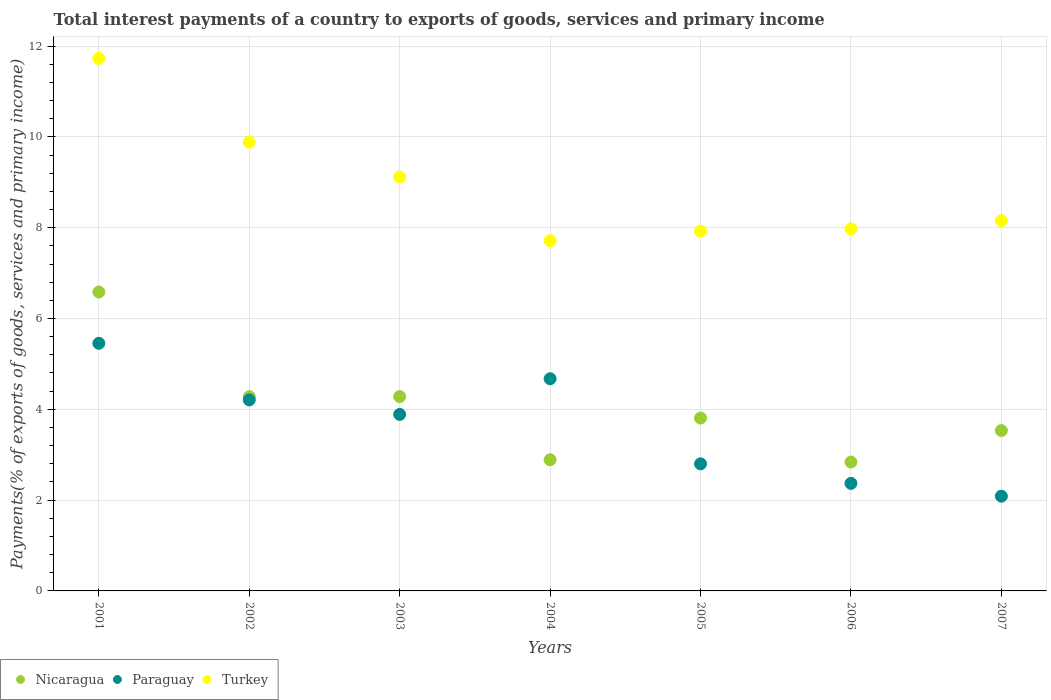How many different coloured dotlines are there?
Keep it short and to the point. 3. Is the number of dotlines equal to the number of legend labels?
Your response must be concise. Yes. What is the total interest payments in Turkey in 2003?
Provide a succinct answer. 9.12. Across all years, what is the maximum total interest payments in Turkey?
Provide a succinct answer. 11.73. Across all years, what is the minimum total interest payments in Nicaragua?
Keep it short and to the point. 2.84. In which year was the total interest payments in Paraguay maximum?
Offer a terse response. 2001. In which year was the total interest payments in Turkey minimum?
Provide a succinct answer. 2004. What is the total total interest payments in Turkey in the graph?
Keep it short and to the point. 62.5. What is the difference between the total interest payments in Nicaragua in 2003 and that in 2005?
Make the answer very short. 0.47. What is the difference between the total interest payments in Nicaragua in 2002 and the total interest payments in Turkey in 2003?
Ensure brevity in your answer.  -4.84. What is the average total interest payments in Turkey per year?
Provide a short and direct response. 8.93. In the year 2007, what is the difference between the total interest payments in Turkey and total interest payments in Paraguay?
Keep it short and to the point. 6.07. In how many years, is the total interest payments in Nicaragua greater than 11.6 %?
Offer a terse response. 0. What is the ratio of the total interest payments in Turkey in 2006 to that in 2007?
Provide a short and direct response. 0.98. Is the difference between the total interest payments in Turkey in 2004 and 2007 greater than the difference between the total interest payments in Paraguay in 2004 and 2007?
Give a very brief answer. No. What is the difference between the highest and the second highest total interest payments in Paraguay?
Your answer should be very brief. 0.78. What is the difference between the highest and the lowest total interest payments in Turkey?
Keep it short and to the point. 4.02. In how many years, is the total interest payments in Nicaragua greater than the average total interest payments in Nicaragua taken over all years?
Provide a succinct answer. 3. How many legend labels are there?
Keep it short and to the point. 3. What is the title of the graph?
Ensure brevity in your answer.  Total interest payments of a country to exports of goods, services and primary income. What is the label or title of the X-axis?
Offer a very short reply. Years. What is the label or title of the Y-axis?
Make the answer very short. Payments(% of exports of goods, services and primary income). What is the Payments(% of exports of goods, services and primary income) of Nicaragua in 2001?
Offer a very short reply. 6.58. What is the Payments(% of exports of goods, services and primary income) of Paraguay in 2001?
Make the answer very short. 5.45. What is the Payments(% of exports of goods, services and primary income) in Turkey in 2001?
Provide a succinct answer. 11.73. What is the Payments(% of exports of goods, services and primary income) in Nicaragua in 2002?
Make the answer very short. 4.28. What is the Payments(% of exports of goods, services and primary income) in Paraguay in 2002?
Provide a short and direct response. 4.21. What is the Payments(% of exports of goods, services and primary income) in Turkey in 2002?
Provide a succinct answer. 9.88. What is the Payments(% of exports of goods, services and primary income) of Nicaragua in 2003?
Offer a very short reply. 4.28. What is the Payments(% of exports of goods, services and primary income) in Paraguay in 2003?
Give a very brief answer. 3.89. What is the Payments(% of exports of goods, services and primary income) in Turkey in 2003?
Make the answer very short. 9.12. What is the Payments(% of exports of goods, services and primary income) of Nicaragua in 2004?
Provide a succinct answer. 2.89. What is the Payments(% of exports of goods, services and primary income) in Paraguay in 2004?
Your answer should be compact. 4.67. What is the Payments(% of exports of goods, services and primary income) of Turkey in 2004?
Ensure brevity in your answer.  7.71. What is the Payments(% of exports of goods, services and primary income) of Nicaragua in 2005?
Your response must be concise. 3.81. What is the Payments(% of exports of goods, services and primary income) of Paraguay in 2005?
Your response must be concise. 2.8. What is the Payments(% of exports of goods, services and primary income) of Turkey in 2005?
Offer a terse response. 7.92. What is the Payments(% of exports of goods, services and primary income) of Nicaragua in 2006?
Provide a succinct answer. 2.84. What is the Payments(% of exports of goods, services and primary income) in Paraguay in 2006?
Give a very brief answer. 2.37. What is the Payments(% of exports of goods, services and primary income) in Turkey in 2006?
Your answer should be very brief. 7.97. What is the Payments(% of exports of goods, services and primary income) of Nicaragua in 2007?
Provide a short and direct response. 3.53. What is the Payments(% of exports of goods, services and primary income) in Paraguay in 2007?
Offer a very short reply. 2.09. What is the Payments(% of exports of goods, services and primary income) in Turkey in 2007?
Your answer should be very brief. 8.16. Across all years, what is the maximum Payments(% of exports of goods, services and primary income) of Nicaragua?
Offer a very short reply. 6.58. Across all years, what is the maximum Payments(% of exports of goods, services and primary income) in Paraguay?
Give a very brief answer. 5.45. Across all years, what is the maximum Payments(% of exports of goods, services and primary income) in Turkey?
Offer a terse response. 11.73. Across all years, what is the minimum Payments(% of exports of goods, services and primary income) of Nicaragua?
Provide a short and direct response. 2.84. Across all years, what is the minimum Payments(% of exports of goods, services and primary income) of Paraguay?
Give a very brief answer. 2.09. Across all years, what is the minimum Payments(% of exports of goods, services and primary income) in Turkey?
Provide a short and direct response. 7.71. What is the total Payments(% of exports of goods, services and primary income) of Nicaragua in the graph?
Your answer should be compact. 28.21. What is the total Payments(% of exports of goods, services and primary income) in Paraguay in the graph?
Give a very brief answer. 25.48. What is the total Payments(% of exports of goods, services and primary income) in Turkey in the graph?
Provide a short and direct response. 62.5. What is the difference between the Payments(% of exports of goods, services and primary income) in Nicaragua in 2001 and that in 2002?
Make the answer very short. 2.31. What is the difference between the Payments(% of exports of goods, services and primary income) of Paraguay in 2001 and that in 2002?
Ensure brevity in your answer.  1.25. What is the difference between the Payments(% of exports of goods, services and primary income) of Turkey in 2001 and that in 2002?
Offer a very short reply. 1.84. What is the difference between the Payments(% of exports of goods, services and primary income) of Nicaragua in 2001 and that in 2003?
Your answer should be very brief. 2.3. What is the difference between the Payments(% of exports of goods, services and primary income) in Paraguay in 2001 and that in 2003?
Offer a terse response. 1.57. What is the difference between the Payments(% of exports of goods, services and primary income) of Turkey in 2001 and that in 2003?
Your answer should be very brief. 2.61. What is the difference between the Payments(% of exports of goods, services and primary income) in Nicaragua in 2001 and that in 2004?
Ensure brevity in your answer.  3.7. What is the difference between the Payments(% of exports of goods, services and primary income) in Paraguay in 2001 and that in 2004?
Give a very brief answer. 0.78. What is the difference between the Payments(% of exports of goods, services and primary income) of Turkey in 2001 and that in 2004?
Provide a short and direct response. 4.02. What is the difference between the Payments(% of exports of goods, services and primary income) in Nicaragua in 2001 and that in 2005?
Your answer should be very brief. 2.78. What is the difference between the Payments(% of exports of goods, services and primary income) of Paraguay in 2001 and that in 2005?
Your answer should be very brief. 2.65. What is the difference between the Payments(% of exports of goods, services and primary income) of Turkey in 2001 and that in 2005?
Provide a short and direct response. 3.8. What is the difference between the Payments(% of exports of goods, services and primary income) in Nicaragua in 2001 and that in 2006?
Provide a succinct answer. 3.74. What is the difference between the Payments(% of exports of goods, services and primary income) of Paraguay in 2001 and that in 2006?
Offer a terse response. 3.08. What is the difference between the Payments(% of exports of goods, services and primary income) of Turkey in 2001 and that in 2006?
Ensure brevity in your answer.  3.75. What is the difference between the Payments(% of exports of goods, services and primary income) of Nicaragua in 2001 and that in 2007?
Provide a succinct answer. 3.05. What is the difference between the Payments(% of exports of goods, services and primary income) of Paraguay in 2001 and that in 2007?
Your response must be concise. 3.37. What is the difference between the Payments(% of exports of goods, services and primary income) in Turkey in 2001 and that in 2007?
Make the answer very short. 3.57. What is the difference between the Payments(% of exports of goods, services and primary income) in Nicaragua in 2002 and that in 2003?
Make the answer very short. -0. What is the difference between the Payments(% of exports of goods, services and primary income) in Paraguay in 2002 and that in 2003?
Your answer should be compact. 0.32. What is the difference between the Payments(% of exports of goods, services and primary income) in Turkey in 2002 and that in 2003?
Your answer should be compact. 0.77. What is the difference between the Payments(% of exports of goods, services and primary income) in Nicaragua in 2002 and that in 2004?
Your answer should be compact. 1.39. What is the difference between the Payments(% of exports of goods, services and primary income) in Paraguay in 2002 and that in 2004?
Your answer should be compact. -0.47. What is the difference between the Payments(% of exports of goods, services and primary income) in Turkey in 2002 and that in 2004?
Your response must be concise. 2.17. What is the difference between the Payments(% of exports of goods, services and primary income) in Nicaragua in 2002 and that in 2005?
Give a very brief answer. 0.47. What is the difference between the Payments(% of exports of goods, services and primary income) of Paraguay in 2002 and that in 2005?
Make the answer very short. 1.41. What is the difference between the Payments(% of exports of goods, services and primary income) of Turkey in 2002 and that in 2005?
Make the answer very short. 1.96. What is the difference between the Payments(% of exports of goods, services and primary income) in Nicaragua in 2002 and that in 2006?
Keep it short and to the point. 1.44. What is the difference between the Payments(% of exports of goods, services and primary income) in Paraguay in 2002 and that in 2006?
Offer a terse response. 1.84. What is the difference between the Payments(% of exports of goods, services and primary income) of Turkey in 2002 and that in 2006?
Your answer should be very brief. 1.91. What is the difference between the Payments(% of exports of goods, services and primary income) in Nicaragua in 2002 and that in 2007?
Your response must be concise. 0.75. What is the difference between the Payments(% of exports of goods, services and primary income) in Paraguay in 2002 and that in 2007?
Your answer should be compact. 2.12. What is the difference between the Payments(% of exports of goods, services and primary income) in Turkey in 2002 and that in 2007?
Provide a short and direct response. 1.73. What is the difference between the Payments(% of exports of goods, services and primary income) of Nicaragua in 2003 and that in 2004?
Make the answer very short. 1.39. What is the difference between the Payments(% of exports of goods, services and primary income) in Paraguay in 2003 and that in 2004?
Provide a succinct answer. -0.79. What is the difference between the Payments(% of exports of goods, services and primary income) in Turkey in 2003 and that in 2004?
Keep it short and to the point. 1.41. What is the difference between the Payments(% of exports of goods, services and primary income) in Nicaragua in 2003 and that in 2005?
Your response must be concise. 0.47. What is the difference between the Payments(% of exports of goods, services and primary income) in Paraguay in 2003 and that in 2005?
Ensure brevity in your answer.  1.09. What is the difference between the Payments(% of exports of goods, services and primary income) of Turkey in 2003 and that in 2005?
Make the answer very short. 1.19. What is the difference between the Payments(% of exports of goods, services and primary income) in Nicaragua in 2003 and that in 2006?
Ensure brevity in your answer.  1.44. What is the difference between the Payments(% of exports of goods, services and primary income) of Paraguay in 2003 and that in 2006?
Keep it short and to the point. 1.52. What is the difference between the Payments(% of exports of goods, services and primary income) of Turkey in 2003 and that in 2006?
Offer a very short reply. 1.14. What is the difference between the Payments(% of exports of goods, services and primary income) of Nicaragua in 2003 and that in 2007?
Give a very brief answer. 0.75. What is the difference between the Payments(% of exports of goods, services and primary income) in Paraguay in 2003 and that in 2007?
Your answer should be very brief. 1.8. What is the difference between the Payments(% of exports of goods, services and primary income) in Turkey in 2003 and that in 2007?
Provide a succinct answer. 0.96. What is the difference between the Payments(% of exports of goods, services and primary income) of Nicaragua in 2004 and that in 2005?
Ensure brevity in your answer.  -0.92. What is the difference between the Payments(% of exports of goods, services and primary income) of Paraguay in 2004 and that in 2005?
Offer a very short reply. 1.87. What is the difference between the Payments(% of exports of goods, services and primary income) in Turkey in 2004 and that in 2005?
Keep it short and to the point. -0.21. What is the difference between the Payments(% of exports of goods, services and primary income) of Nicaragua in 2004 and that in 2006?
Provide a succinct answer. 0.05. What is the difference between the Payments(% of exports of goods, services and primary income) of Paraguay in 2004 and that in 2006?
Your answer should be compact. 2.3. What is the difference between the Payments(% of exports of goods, services and primary income) in Turkey in 2004 and that in 2006?
Your answer should be very brief. -0.26. What is the difference between the Payments(% of exports of goods, services and primary income) in Nicaragua in 2004 and that in 2007?
Ensure brevity in your answer.  -0.64. What is the difference between the Payments(% of exports of goods, services and primary income) in Paraguay in 2004 and that in 2007?
Give a very brief answer. 2.59. What is the difference between the Payments(% of exports of goods, services and primary income) in Turkey in 2004 and that in 2007?
Ensure brevity in your answer.  -0.44. What is the difference between the Payments(% of exports of goods, services and primary income) of Nicaragua in 2005 and that in 2006?
Give a very brief answer. 0.97. What is the difference between the Payments(% of exports of goods, services and primary income) of Paraguay in 2005 and that in 2006?
Provide a short and direct response. 0.43. What is the difference between the Payments(% of exports of goods, services and primary income) in Turkey in 2005 and that in 2006?
Offer a very short reply. -0.05. What is the difference between the Payments(% of exports of goods, services and primary income) of Nicaragua in 2005 and that in 2007?
Provide a succinct answer. 0.28. What is the difference between the Payments(% of exports of goods, services and primary income) of Paraguay in 2005 and that in 2007?
Offer a very short reply. 0.71. What is the difference between the Payments(% of exports of goods, services and primary income) in Turkey in 2005 and that in 2007?
Give a very brief answer. -0.23. What is the difference between the Payments(% of exports of goods, services and primary income) in Nicaragua in 2006 and that in 2007?
Your answer should be compact. -0.69. What is the difference between the Payments(% of exports of goods, services and primary income) of Paraguay in 2006 and that in 2007?
Give a very brief answer. 0.28. What is the difference between the Payments(% of exports of goods, services and primary income) of Turkey in 2006 and that in 2007?
Provide a succinct answer. -0.18. What is the difference between the Payments(% of exports of goods, services and primary income) in Nicaragua in 2001 and the Payments(% of exports of goods, services and primary income) in Paraguay in 2002?
Ensure brevity in your answer.  2.38. What is the difference between the Payments(% of exports of goods, services and primary income) of Nicaragua in 2001 and the Payments(% of exports of goods, services and primary income) of Turkey in 2002?
Ensure brevity in your answer.  -3.3. What is the difference between the Payments(% of exports of goods, services and primary income) of Paraguay in 2001 and the Payments(% of exports of goods, services and primary income) of Turkey in 2002?
Your answer should be compact. -4.43. What is the difference between the Payments(% of exports of goods, services and primary income) of Nicaragua in 2001 and the Payments(% of exports of goods, services and primary income) of Paraguay in 2003?
Your answer should be compact. 2.7. What is the difference between the Payments(% of exports of goods, services and primary income) in Nicaragua in 2001 and the Payments(% of exports of goods, services and primary income) in Turkey in 2003?
Keep it short and to the point. -2.54. What is the difference between the Payments(% of exports of goods, services and primary income) in Paraguay in 2001 and the Payments(% of exports of goods, services and primary income) in Turkey in 2003?
Your response must be concise. -3.67. What is the difference between the Payments(% of exports of goods, services and primary income) of Nicaragua in 2001 and the Payments(% of exports of goods, services and primary income) of Paraguay in 2004?
Your answer should be very brief. 1.91. What is the difference between the Payments(% of exports of goods, services and primary income) of Nicaragua in 2001 and the Payments(% of exports of goods, services and primary income) of Turkey in 2004?
Make the answer very short. -1.13. What is the difference between the Payments(% of exports of goods, services and primary income) in Paraguay in 2001 and the Payments(% of exports of goods, services and primary income) in Turkey in 2004?
Provide a short and direct response. -2.26. What is the difference between the Payments(% of exports of goods, services and primary income) in Nicaragua in 2001 and the Payments(% of exports of goods, services and primary income) in Paraguay in 2005?
Ensure brevity in your answer.  3.78. What is the difference between the Payments(% of exports of goods, services and primary income) of Nicaragua in 2001 and the Payments(% of exports of goods, services and primary income) of Turkey in 2005?
Give a very brief answer. -1.34. What is the difference between the Payments(% of exports of goods, services and primary income) of Paraguay in 2001 and the Payments(% of exports of goods, services and primary income) of Turkey in 2005?
Offer a very short reply. -2.47. What is the difference between the Payments(% of exports of goods, services and primary income) of Nicaragua in 2001 and the Payments(% of exports of goods, services and primary income) of Paraguay in 2006?
Your answer should be compact. 4.22. What is the difference between the Payments(% of exports of goods, services and primary income) in Nicaragua in 2001 and the Payments(% of exports of goods, services and primary income) in Turkey in 2006?
Your answer should be very brief. -1.39. What is the difference between the Payments(% of exports of goods, services and primary income) of Paraguay in 2001 and the Payments(% of exports of goods, services and primary income) of Turkey in 2006?
Provide a short and direct response. -2.52. What is the difference between the Payments(% of exports of goods, services and primary income) of Nicaragua in 2001 and the Payments(% of exports of goods, services and primary income) of Paraguay in 2007?
Your answer should be compact. 4.5. What is the difference between the Payments(% of exports of goods, services and primary income) of Nicaragua in 2001 and the Payments(% of exports of goods, services and primary income) of Turkey in 2007?
Your answer should be very brief. -1.57. What is the difference between the Payments(% of exports of goods, services and primary income) of Paraguay in 2001 and the Payments(% of exports of goods, services and primary income) of Turkey in 2007?
Offer a very short reply. -2.7. What is the difference between the Payments(% of exports of goods, services and primary income) in Nicaragua in 2002 and the Payments(% of exports of goods, services and primary income) in Paraguay in 2003?
Make the answer very short. 0.39. What is the difference between the Payments(% of exports of goods, services and primary income) of Nicaragua in 2002 and the Payments(% of exports of goods, services and primary income) of Turkey in 2003?
Provide a short and direct response. -4.84. What is the difference between the Payments(% of exports of goods, services and primary income) of Paraguay in 2002 and the Payments(% of exports of goods, services and primary income) of Turkey in 2003?
Provide a succinct answer. -4.91. What is the difference between the Payments(% of exports of goods, services and primary income) in Nicaragua in 2002 and the Payments(% of exports of goods, services and primary income) in Paraguay in 2004?
Keep it short and to the point. -0.4. What is the difference between the Payments(% of exports of goods, services and primary income) in Nicaragua in 2002 and the Payments(% of exports of goods, services and primary income) in Turkey in 2004?
Your response must be concise. -3.43. What is the difference between the Payments(% of exports of goods, services and primary income) in Paraguay in 2002 and the Payments(% of exports of goods, services and primary income) in Turkey in 2004?
Provide a succinct answer. -3.51. What is the difference between the Payments(% of exports of goods, services and primary income) in Nicaragua in 2002 and the Payments(% of exports of goods, services and primary income) in Paraguay in 2005?
Give a very brief answer. 1.48. What is the difference between the Payments(% of exports of goods, services and primary income) of Nicaragua in 2002 and the Payments(% of exports of goods, services and primary income) of Turkey in 2005?
Keep it short and to the point. -3.65. What is the difference between the Payments(% of exports of goods, services and primary income) of Paraguay in 2002 and the Payments(% of exports of goods, services and primary income) of Turkey in 2005?
Offer a very short reply. -3.72. What is the difference between the Payments(% of exports of goods, services and primary income) in Nicaragua in 2002 and the Payments(% of exports of goods, services and primary income) in Paraguay in 2006?
Offer a very short reply. 1.91. What is the difference between the Payments(% of exports of goods, services and primary income) in Nicaragua in 2002 and the Payments(% of exports of goods, services and primary income) in Turkey in 2006?
Give a very brief answer. -3.7. What is the difference between the Payments(% of exports of goods, services and primary income) of Paraguay in 2002 and the Payments(% of exports of goods, services and primary income) of Turkey in 2006?
Make the answer very short. -3.77. What is the difference between the Payments(% of exports of goods, services and primary income) in Nicaragua in 2002 and the Payments(% of exports of goods, services and primary income) in Paraguay in 2007?
Provide a succinct answer. 2.19. What is the difference between the Payments(% of exports of goods, services and primary income) in Nicaragua in 2002 and the Payments(% of exports of goods, services and primary income) in Turkey in 2007?
Ensure brevity in your answer.  -3.88. What is the difference between the Payments(% of exports of goods, services and primary income) in Paraguay in 2002 and the Payments(% of exports of goods, services and primary income) in Turkey in 2007?
Ensure brevity in your answer.  -3.95. What is the difference between the Payments(% of exports of goods, services and primary income) of Nicaragua in 2003 and the Payments(% of exports of goods, services and primary income) of Paraguay in 2004?
Keep it short and to the point. -0.39. What is the difference between the Payments(% of exports of goods, services and primary income) of Nicaragua in 2003 and the Payments(% of exports of goods, services and primary income) of Turkey in 2004?
Ensure brevity in your answer.  -3.43. What is the difference between the Payments(% of exports of goods, services and primary income) of Paraguay in 2003 and the Payments(% of exports of goods, services and primary income) of Turkey in 2004?
Your answer should be compact. -3.82. What is the difference between the Payments(% of exports of goods, services and primary income) in Nicaragua in 2003 and the Payments(% of exports of goods, services and primary income) in Paraguay in 2005?
Keep it short and to the point. 1.48. What is the difference between the Payments(% of exports of goods, services and primary income) of Nicaragua in 2003 and the Payments(% of exports of goods, services and primary income) of Turkey in 2005?
Offer a terse response. -3.64. What is the difference between the Payments(% of exports of goods, services and primary income) in Paraguay in 2003 and the Payments(% of exports of goods, services and primary income) in Turkey in 2005?
Keep it short and to the point. -4.04. What is the difference between the Payments(% of exports of goods, services and primary income) of Nicaragua in 2003 and the Payments(% of exports of goods, services and primary income) of Paraguay in 2006?
Offer a terse response. 1.91. What is the difference between the Payments(% of exports of goods, services and primary income) in Nicaragua in 2003 and the Payments(% of exports of goods, services and primary income) in Turkey in 2006?
Your answer should be compact. -3.69. What is the difference between the Payments(% of exports of goods, services and primary income) of Paraguay in 2003 and the Payments(% of exports of goods, services and primary income) of Turkey in 2006?
Ensure brevity in your answer.  -4.09. What is the difference between the Payments(% of exports of goods, services and primary income) of Nicaragua in 2003 and the Payments(% of exports of goods, services and primary income) of Paraguay in 2007?
Provide a short and direct response. 2.19. What is the difference between the Payments(% of exports of goods, services and primary income) in Nicaragua in 2003 and the Payments(% of exports of goods, services and primary income) in Turkey in 2007?
Your answer should be very brief. -3.88. What is the difference between the Payments(% of exports of goods, services and primary income) of Paraguay in 2003 and the Payments(% of exports of goods, services and primary income) of Turkey in 2007?
Provide a succinct answer. -4.27. What is the difference between the Payments(% of exports of goods, services and primary income) in Nicaragua in 2004 and the Payments(% of exports of goods, services and primary income) in Paraguay in 2005?
Provide a short and direct response. 0.09. What is the difference between the Payments(% of exports of goods, services and primary income) of Nicaragua in 2004 and the Payments(% of exports of goods, services and primary income) of Turkey in 2005?
Ensure brevity in your answer.  -5.04. What is the difference between the Payments(% of exports of goods, services and primary income) of Paraguay in 2004 and the Payments(% of exports of goods, services and primary income) of Turkey in 2005?
Keep it short and to the point. -3.25. What is the difference between the Payments(% of exports of goods, services and primary income) in Nicaragua in 2004 and the Payments(% of exports of goods, services and primary income) in Paraguay in 2006?
Provide a short and direct response. 0.52. What is the difference between the Payments(% of exports of goods, services and primary income) in Nicaragua in 2004 and the Payments(% of exports of goods, services and primary income) in Turkey in 2006?
Offer a very short reply. -5.09. What is the difference between the Payments(% of exports of goods, services and primary income) in Paraguay in 2004 and the Payments(% of exports of goods, services and primary income) in Turkey in 2006?
Provide a succinct answer. -3.3. What is the difference between the Payments(% of exports of goods, services and primary income) of Nicaragua in 2004 and the Payments(% of exports of goods, services and primary income) of Paraguay in 2007?
Keep it short and to the point. 0.8. What is the difference between the Payments(% of exports of goods, services and primary income) of Nicaragua in 2004 and the Payments(% of exports of goods, services and primary income) of Turkey in 2007?
Offer a terse response. -5.27. What is the difference between the Payments(% of exports of goods, services and primary income) of Paraguay in 2004 and the Payments(% of exports of goods, services and primary income) of Turkey in 2007?
Your response must be concise. -3.48. What is the difference between the Payments(% of exports of goods, services and primary income) in Nicaragua in 2005 and the Payments(% of exports of goods, services and primary income) in Paraguay in 2006?
Make the answer very short. 1.44. What is the difference between the Payments(% of exports of goods, services and primary income) in Nicaragua in 2005 and the Payments(% of exports of goods, services and primary income) in Turkey in 2006?
Provide a succinct answer. -4.17. What is the difference between the Payments(% of exports of goods, services and primary income) in Paraguay in 2005 and the Payments(% of exports of goods, services and primary income) in Turkey in 2006?
Make the answer very short. -5.18. What is the difference between the Payments(% of exports of goods, services and primary income) in Nicaragua in 2005 and the Payments(% of exports of goods, services and primary income) in Paraguay in 2007?
Ensure brevity in your answer.  1.72. What is the difference between the Payments(% of exports of goods, services and primary income) of Nicaragua in 2005 and the Payments(% of exports of goods, services and primary income) of Turkey in 2007?
Provide a succinct answer. -4.35. What is the difference between the Payments(% of exports of goods, services and primary income) of Paraguay in 2005 and the Payments(% of exports of goods, services and primary income) of Turkey in 2007?
Your answer should be very brief. -5.36. What is the difference between the Payments(% of exports of goods, services and primary income) of Nicaragua in 2006 and the Payments(% of exports of goods, services and primary income) of Paraguay in 2007?
Your answer should be compact. 0.75. What is the difference between the Payments(% of exports of goods, services and primary income) of Nicaragua in 2006 and the Payments(% of exports of goods, services and primary income) of Turkey in 2007?
Give a very brief answer. -5.32. What is the difference between the Payments(% of exports of goods, services and primary income) in Paraguay in 2006 and the Payments(% of exports of goods, services and primary income) in Turkey in 2007?
Your answer should be very brief. -5.79. What is the average Payments(% of exports of goods, services and primary income) of Nicaragua per year?
Make the answer very short. 4.03. What is the average Payments(% of exports of goods, services and primary income) of Paraguay per year?
Keep it short and to the point. 3.64. What is the average Payments(% of exports of goods, services and primary income) of Turkey per year?
Provide a succinct answer. 8.93. In the year 2001, what is the difference between the Payments(% of exports of goods, services and primary income) of Nicaragua and Payments(% of exports of goods, services and primary income) of Paraguay?
Your answer should be very brief. 1.13. In the year 2001, what is the difference between the Payments(% of exports of goods, services and primary income) of Nicaragua and Payments(% of exports of goods, services and primary income) of Turkey?
Ensure brevity in your answer.  -5.14. In the year 2001, what is the difference between the Payments(% of exports of goods, services and primary income) in Paraguay and Payments(% of exports of goods, services and primary income) in Turkey?
Your answer should be compact. -6.27. In the year 2002, what is the difference between the Payments(% of exports of goods, services and primary income) in Nicaragua and Payments(% of exports of goods, services and primary income) in Paraguay?
Ensure brevity in your answer.  0.07. In the year 2002, what is the difference between the Payments(% of exports of goods, services and primary income) of Nicaragua and Payments(% of exports of goods, services and primary income) of Turkey?
Provide a short and direct response. -5.61. In the year 2002, what is the difference between the Payments(% of exports of goods, services and primary income) of Paraguay and Payments(% of exports of goods, services and primary income) of Turkey?
Your answer should be compact. -5.68. In the year 2003, what is the difference between the Payments(% of exports of goods, services and primary income) in Nicaragua and Payments(% of exports of goods, services and primary income) in Paraguay?
Provide a succinct answer. 0.39. In the year 2003, what is the difference between the Payments(% of exports of goods, services and primary income) in Nicaragua and Payments(% of exports of goods, services and primary income) in Turkey?
Provide a short and direct response. -4.84. In the year 2003, what is the difference between the Payments(% of exports of goods, services and primary income) in Paraguay and Payments(% of exports of goods, services and primary income) in Turkey?
Provide a succinct answer. -5.23. In the year 2004, what is the difference between the Payments(% of exports of goods, services and primary income) of Nicaragua and Payments(% of exports of goods, services and primary income) of Paraguay?
Provide a short and direct response. -1.79. In the year 2004, what is the difference between the Payments(% of exports of goods, services and primary income) in Nicaragua and Payments(% of exports of goods, services and primary income) in Turkey?
Ensure brevity in your answer.  -4.82. In the year 2004, what is the difference between the Payments(% of exports of goods, services and primary income) in Paraguay and Payments(% of exports of goods, services and primary income) in Turkey?
Provide a short and direct response. -3.04. In the year 2005, what is the difference between the Payments(% of exports of goods, services and primary income) in Nicaragua and Payments(% of exports of goods, services and primary income) in Paraguay?
Ensure brevity in your answer.  1.01. In the year 2005, what is the difference between the Payments(% of exports of goods, services and primary income) of Nicaragua and Payments(% of exports of goods, services and primary income) of Turkey?
Your answer should be very brief. -4.12. In the year 2005, what is the difference between the Payments(% of exports of goods, services and primary income) of Paraguay and Payments(% of exports of goods, services and primary income) of Turkey?
Offer a terse response. -5.13. In the year 2006, what is the difference between the Payments(% of exports of goods, services and primary income) in Nicaragua and Payments(% of exports of goods, services and primary income) in Paraguay?
Provide a short and direct response. 0.47. In the year 2006, what is the difference between the Payments(% of exports of goods, services and primary income) of Nicaragua and Payments(% of exports of goods, services and primary income) of Turkey?
Keep it short and to the point. -5.14. In the year 2006, what is the difference between the Payments(% of exports of goods, services and primary income) in Paraguay and Payments(% of exports of goods, services and primary income) in Turkey?
Keep it short and to the point. -5.61. In the year 2007, what is the difference between the Payments(% of exports of goods, services and primary income) of Nicaragua and Payments(% of exports of goods, services and primary income) of Paraguay?
Your answer should be compact. 1.45. In the year 2007, what is the difference between the Payments(% of exports of goods, services and primary income) in Nicaragua and Payments(% of exports of goods, services and primary income) in Turkey?
Keep it short and to the point. -4.62. In the year 2007, what is the difference between the Payments(% of exports of goods, services and primary income) in Paraguay and Payments(% of exports of goods, services and primary income) in Turkey?
Offer a terse response. -6.07. What is the ratio of the Payments(% of exports of goods, services and primary income) of Nicaragua in 2001 to that in 2002?
Offer a very short reply. 1.54. What is the ratio of the Payments(% of exports of goods, services and primary income) of Paraguay in 2001 to that in 2002?
Offer a terse response. 1.3. What is the ratio of the Payments(% of exports of goods, services and primary income) of Turkey in 2001 to that in 2002?
Offer a terse response. 1.19. What is the ratio of the Payments(% of exports of goods, services and primary income) of Nicaragua in 2001 to that in 2003?
Offer a terse response. 1.54. What is the ratio of the Payments(% of exports of goods, services and primary income) in Paraguay in 2001 to that in 2003?
Offer a very short reply. 1.4. What is the ratio of the Payments(% of exports of goods, services and primary income) of Turkey in 2001 to that in 2003?
Your response must be concise. 1.29. What is the ratio of the Payments(% of exports of goods, services and primary income) of Nicaragua in 2001 to that in 2004?
Your answer should be compact. 2.28. What is the ratio of the Payments(% of exports of goods, services and primary income) in Paraguay in 2001 to that in 2004?
Make the answer very short. 1.17. What is the ratio of the Payments(% of exports of goods, services and primary income) in Turkey in 2001 to that in 2004?
Provide a succinct answer. 1.52. What is the ratio of the Payments(% of exports of goods, services and primary income) in Nicaragua in 2001 to that in 2005?
Your answer should be compact. 1.73. What is the ratio of the Payments(% of exports of goods, services and primary income) in Paraguay in 2001 to that in 2005?
Keep it short and to the point. 1.95. What is the ratio of the Payments(% of exports of goods, services and primary income) of Turkey in 2001 to that in 2005?
Ensure brevity in your answer.  1.48. What is the ratio of the Payments(% of exports of goods, services and primary income) of Nicaragua in 2001 to that in 2006?
Your response must be concise. 2.32. What is the ratio of the Payments(% of exports of goods, services and primary income) in Paraguay in 2001 to that in 2006?
Ensure brevity in your answer.  2.3. What is the ratio of the Payments(% of exports of goods, services and primary income) in Turkey in 2001 to that in 2006?
Your response must be concise. 1.47. What is the ratio of the Payments(% of exports of goods, services and primary income) of Nicaragua in 2001 to that in 2007?
Keep it short and to the point. 1.86. What is the ratio of the Payments(% of exports of goods, services and primary income) in Paraguay in 2001 to that in 2007?
Your response must be concise. 2.61. What is the ratio of the Payments(% of exports of goods, services and primary income) in Turkey in 2001 to that in 2007?
Your answer should be very brief. 1.44. What is the ratio of the Payments(% of exports of goods, services and primary income) of Nicaragua in 2002 to that in 2003?
Offer a very short reply. 1. What is the ratio of the Payments(% of exports of goods, services and primary income) of Paraguay in 2002 to that in 2003?
Make the answer very short. 1.08. What is the ratio of the Payments(% of exports of goods, services and primary income) of Turkey in 2002 to that in 2003?
Provide a short and direct response. 1.08. What is the ratio of the Payments(% of exports of goods, services and primary income) of Nicaragua in 2002 to that in 2004?
Provide a succinct answer. 1.48. What is the ratio of the Payments(% of exports of goods, services and primary income) of Paraguay in 2002 to that in 2004?
Keep it short and to the point. 0.9. What is the ratio of the Payments(% of exports of goods, services and primary income) of Turkey in 2002 to that in 2004?
Give a very brief answer. 1.28. What is the ratio of the Payments(% of exports of goods, services and primary income) in Nicaragua in 2002 to that in 2005?
Your answer should be very brief. 1.12. What is the ratio of the Payments(% of exports of goods, services and primary income) of Paraguay in 2002 to that in 2005?
Ensure brevity in your answer.  1.5. What is the ratio of the Payments(% of exports of goods, services and primary income) of Turkey in 2002 to that in 2005?
Your response must be concise. 1.25. What is the ratio of the Payments(% of exports of goods, services and primary income) of Nicaragua in 2002 to that in 2006?
Give a very brief answer. 1.51. What is the ratio of the Payments(% of exports of goods, services and primary income) in Paraguay in 2002 to that in 2006?
Make the answer very short. 1.78. What is the ratio of the Payments(% of exports of goods, services and primary income) in Turkey in 2002 to that in 2006?
Provide a succinct answer. 1.24. What is the ratio of the Payments(% of exports of goods, services and primary income) in Nicaragua in 2002 to that in 2007?
Give a very brief answer. 1.21. What is the ratio of the Payments(% of exports of goods, services and primary income) of Paraguay in 2002 to that in 2007?
Keep it short and to the point. 2.02. What is the ratio of the Payments(% of exports of goods, services and primary income) of Turkey in 2002 to that in 2007?
Provide a succinct answer. 1.21. What is the ratio of the Payments(% of exports of goods, services and primary income) in Nicaragua in 2003 to that in 2004?
Offer a terse response. 1.48. What is the ratio of the Payments(% of exports of goods, services and primary income) of Paraguay in 2003 to that in 2004?
Provide a short and direct response. 0.83. What is the ratio of the Payments(% of exports of goods, services and primary income) of Turkey in 2003 to that in 2004?
Make the answer very short. 1.18. What is the ratio of the Payments(% of exports of goods, services and primary income) of Nicaragua in 2003 to that in 2005?
Give a very brief answer. 1.12. What is the ratio of the Payments(% of exports of goods, services and primary income) of Paraguay in 2003 to that in 2005?
Offer a very short reply. 1.39. What is the ratio of the Payments(% of exports of goods, services and primary income) in Turkey in 2003 to that in 2005?
Make the answer very short. 1.15. What is the ratio of the Payments(% of exports of goods, services and primary income) in Nicaragua in 2003 to that in 2006?
Offer a very short reply. 1.51. What is the ratio of the Payments(% of exports of goods, services and primary income) of Paraguay in 2003 to that in 2006?
Your response must be concise. 1.64. What is the ratio of the Payments(% of exports of goods, services and primary income) of Turkey in 2003 to that in 2006?
Make the answer very short. 1.14. What is the ratio of the Payments(% of exports of goods, services and primary income) in Nicaragua in 2003 to that in 2007?
Your answer should be very brief. 1.21. What is the ratio of the Payments(% of exports of goods, services and primary income) of Paraguay in 2003 to that in 2007?
Provide a succinct answer. 1.86. What is the ratio of the Payments(% of exports of goods, services and primary income) in Turkey in 2003 to that in 2007?
Keep it short and to the point. 1.12. What is the ratio of the Payments(% of exports of goods, services and primary income) of Nicaragua in 2004 to that in 2005?
Your answer should be compact. 0.76. What is the ratio of the Payments(% of exports of goods, services and primary income) in Paraguay in 2004 to that in 2005?
Your answer should be compact. 1.67. What is the ratio of the Payments(% of exports of goods, services and primary income) of Turkey in 2004 to that in 2005?
Make the answer very short. 0.97. What is the ratio of the Payments(% of exports of goods, services and primary income) of Nicaragua in 2004 to that in 2006?
Your response must be concise. 1.02. What is the ratio of the Payments(% of exports of goods, services and primary income) in Paraguay in 2004 to that in 2006?
Your answer should be compact. 1.97. What is the ratio of the Payments(% of exports of goods, services and primary income) in Turkey in 2004 to that in 2006?
Offer a very short reply. 0.97. What is the ratio of the Payments(% of exports of goods, services and primary income) of Nicaragua in 2004 to that in 2007?
Your answer should be very brief. 0.82. What is the ratio of the Payments(% of exports of goods, services and primary income) of Paraguay in 2004 to that in 2007?
Your answer should be very brief. 2.24. What is the ratio of the Payments(% of exports of goods, services and primary income) of Turkey in 2004 to that in 2007?
Ensure brevity in your answer.  0.95. What is the ratio of the Payments(% of exports of goods, services and primary income) of Nicaragua in 2005 to that in 2006?
Ensure brevity in your answer.  1.34. What is the ratio of the Payments(% of exports of goods, services and primary income) in Paraguay in 2005 to that in 2006?
Your response must be concise. 1.18. What is the ratio of the Payments(% of exports of goods, services and primary income) of Nicaragua in 2005 to that in 2007?
Ensure brevity in your answer.  1.08. What is the ratio of the Payments(% of exports of goods, services and primary income) in Paraguay in 2005 to that in 2007?
Offer a very short reply. 1.34. What is the ratio of the Payments(% of exports of goods, services and primary income) in Turkey in 2005 to that in 2007?
Your answer should be very brief. 0.97. What is the ratio of the Payments(% of exports of goods, services and primary income) in Nicaragua in 2006 to that in 2007?
Keep it short and to the point. 0.8. What is the ratio of the Payments(% of exports of goods, services and primary income) of Paraguay in 2006 to that in 2007?
Make the answer very short. 1.13. What is the ratio of the Payments(% of exports of goods, services and primary income) of Turkey in 2006 to that in 2007?
Provide a succinct answer. 0.98. What is the difference between the highest and the second highest Payments(% of exports of goods, services and primary income) in Nicaragua?
Offer a terse response. 2.3. What is the difference between the highest and the second highest Payments(% of exports of goods, services and primary income) in Paraguay?
Keep it short and to the point. 0.78. What is the difference between the highest and the second highest Payments(% of exports of goods, services and primary income) in Turkey?
Give a very brief answer. 1.84. What is the difference between the highest and the lowest Payments(% of exports of goods, services and primary income) in Nicaragua?
Your answer should be compact. 3.74. What is the difference between the highest and the lowest Payments(% of exports of goods, services and primary income) of Paraguay?
Provide a succinct answer. 3.37. What is the difference between the highest and the lowest Payments(% of exports of goods, services and primary income) in Turkey?
Offer a terse response. 4.02. 